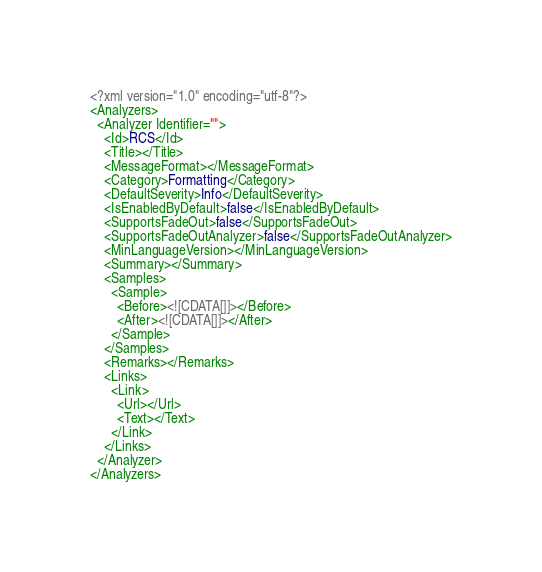<code> <loc_0><loc_0><loc_500><loc_500><_XML_><?xml version="1.0" encoding="utf-8"?>
<Analyzers>
  <Analyzer Identifier="">
    <Id>RCS</Id>
    <Title></Title>
    <MessageFormat></MessageFormat>
    <Category>Formatting</Category>
    <DefaultSeverity>Info</DefaultSeverity>
    <IsEnabledByDefault>false</IsEnabledByDefault>
    <SupportsFadeOut>false</SupportsFadeOut>
    <SupportsFadeOutAnalyzer>false</SupportsFadeOutAnalyzer>
    <MinLanguageVersion></MinLanguageVersion>
    <Summary></Summary>
    <Samples>
      <Sample>
        <Before><![CDATA[]]></Before>
        <After><![CDATA[]]></After>
      </Sample>
    </Samples>
    <Remarks></Remarks>
    <Links>
      <Link>
        <Url></Url>
        <Text></Text>
      </Link>
    </Links>
  </Analyzer>
</Analyzers></code> 